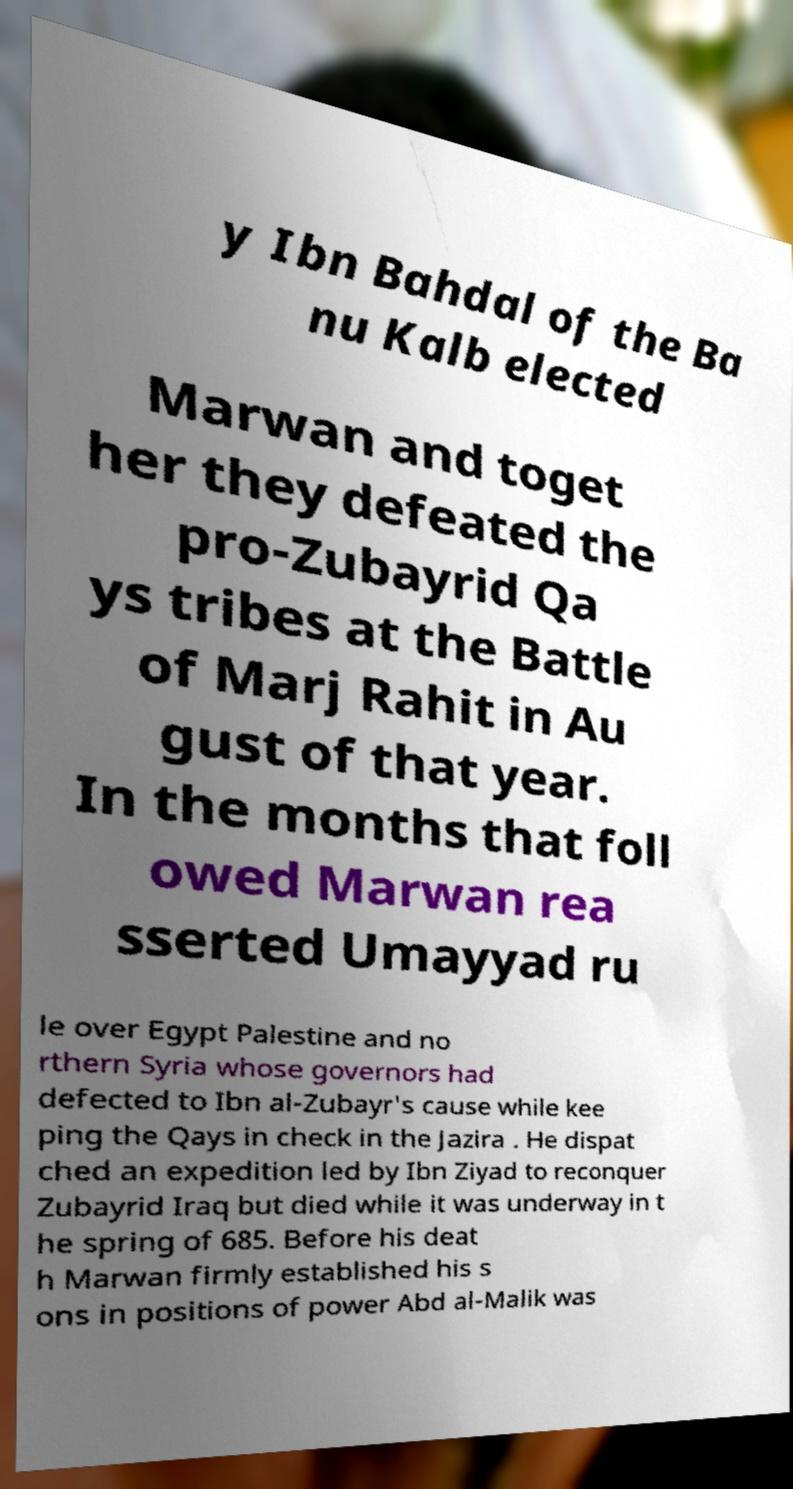Could you assist in decoding the text presented in this image and type it out clearly? y Ibn Bahdal of the Ba nu Kalb elected Marwan and toget her they defeated the pro-Zubayrid Qa ys tribes at the Battle of Marj Rahit in Au gust of that year. In the months that foll owed Marwan rea sserted Umayyad ru le over Egypt Palestine and no rthern Syria whose governors had defected to Ibn al-Zubayr's cause while kee ping the Qays in check in the Jazira . He dispat ched an expedition led by Ibn Ziyad to reconquer Zubayrid Iraq but died while it was underway in t he spring of 685. Before his deat h Marwan firmly established his s ons in positions of power Abd al-Malik was 